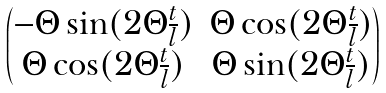Convert formula to latex. <formula><loc_0><loc_0><loc_500><loc_500>\begin{pmatrix} - \Theta \sin ( 2 \Theta \frac { t } { l } ) & \Theta \cos ( 2 \Theta \frac { t } { l } ) \\ \Theta \cos ( 2 \Theta \frac { t } { l } ) & \Theta \sin ( 2 \Theta \frac { t } { l } ) \end{pmatrix}</formula> 